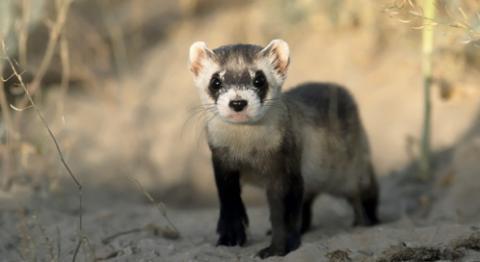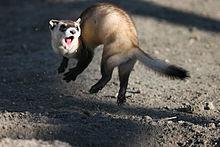The first image is the image on the left, the second image is the image on the right. Assess this claim about the two images: "One animal is in a hole, one animal is not, and there is not a third animal.". Correct or not? Answer yes or no. No. The first image is the image on the left, the second image is the image on the right. Given the left and right images, does the statement "An animal's head and neck are visible just outside a hole." hold true? Answer yes or no. No. 